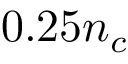<formula> <loc_0><loc_0><loc_500><loc_500>0 . 2 5 n _ { c }</formula> 